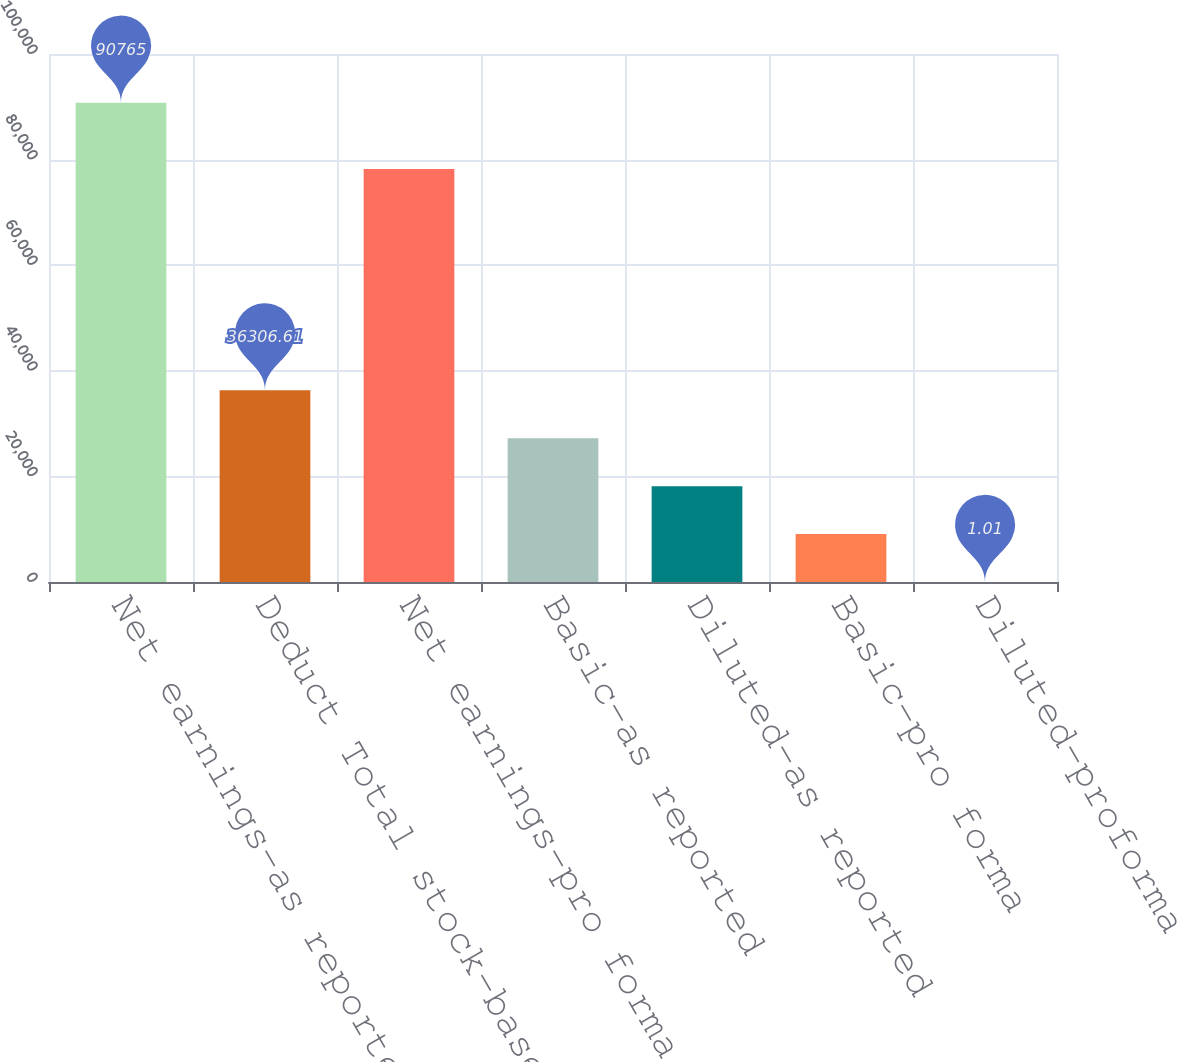Convert chart to OTSL. <chart><loc_0><loc_0><loc_500><loc_500><bar_chart><fcel>Net earnings-as reported<fcel>Deduct Total stock-based<fcel>Net earnings-pro forma<fcel>Basic-as reported<fcel>Diluted-as reported<fcel>Basic-pro forma<fcel>Diluted-proforma<nl><fcel>90765<fcel>36306.6<fcel>78211<fcel>27230.2<fcel>18153.8<fcel>9077.41<fcel>1.01<nl></chart> 